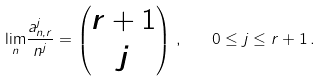Convert formula to latex. <formula><loc_0><loc_0><loc_500><loc_500>\underset { n } \lim \frac { a _ { n , r } ^ { j } } { n ^ { j } } = \left ( \begin{matrix} r + 1 \\ j \end{matrix} \right ) \, , \quad 0 \leq j \leq r + 1 \, .</formula> 